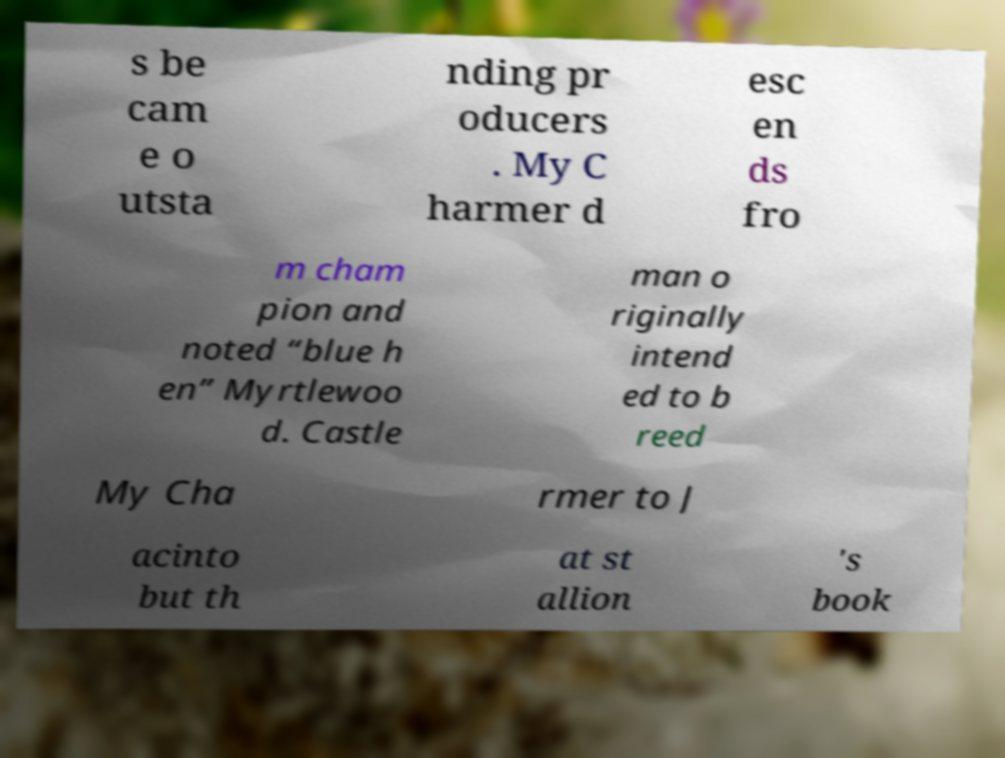Please identify and transcribe the text found in this image. s be cam e o utsta nding pr oducers . My C harmer d esc en ds fro m cham pion and noted “blue h en” Myrtlewoo d. Castle man o riginally intend ed to b reed My Cha rmer to J acinto but th at st allion 's book 